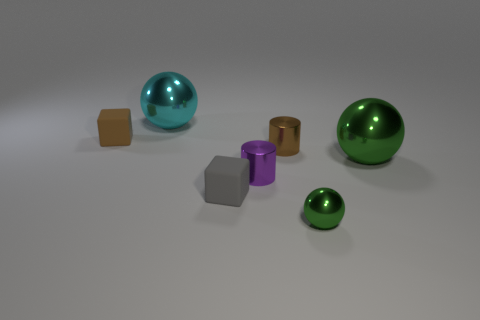Add 1 yellow shiny cylinders. How many objects exist? 8 Subtract all balls. How many objects are left? 4 Add 7 brown objects. How many brown objects exist? 9 Subtract 0 blue blocks. How many objects are left? 7 Subtract all yellow shiny blocks. Subtract all small rubber cubes. How many objects are left? 5 Add 7 big green metallic balls. How many big green metallic balls are left? 8 